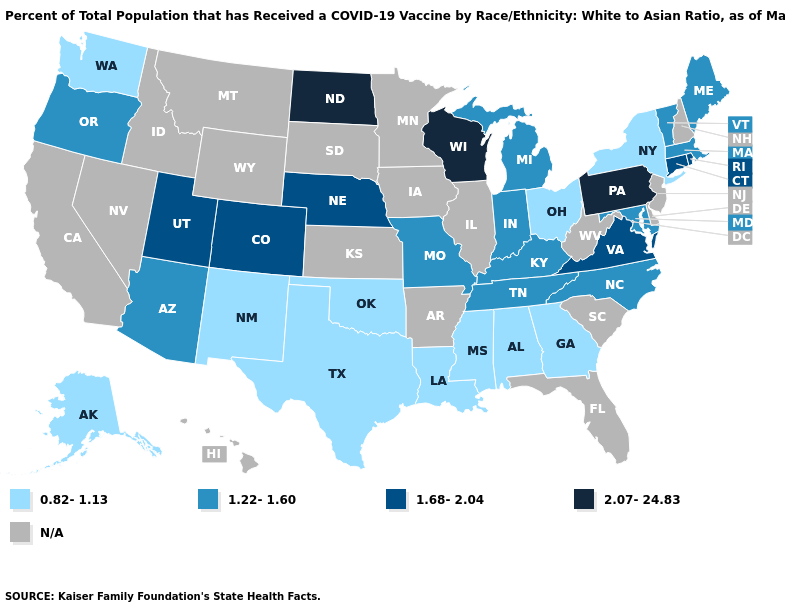Is the legend a continuous bar?
Keep it brief. No. Does Indiana have the lowest value in the USA?
Concise answer only. No. What is the lowest value in states that border Mississippi?
Answer briefly. 0.82-1.13. What is the value of California?
Give a very brief answer. N/A. Does the first symbol in the legend represent the smallest category?
Write a very short answer. Yes. Among the states that border Delaware , which have the highest value?
Write a very short answer. Pennsylvania. What is the lowest value in the West?
Quick response, please. 0.82-1.13. Name the states that have a value in the range 1.68-2.04?
Be succinct. Colorado, Connecticut, Nebraska, Rhode Island, Utah, Virginia. Does the first symbol in the legend represent the smallest category?
Concise answer only. Yes. How many symbols are there in the legend?
Answer briefly. 5. What is the value of New York?
Keep it brief. 0.82-1.13. Is the legend a continuous bar?
Answer briefly. No. Which states have the lowest value in the USA?
Give a very brief answer. Alabama, Alaska, Georgia, Louisiana, Mississippi, New Mexico, New York, Ohio, Oklahoma, Texas, Washington. Which states have the lowest value in the USA?
Keep it brief. Alabama, Alaska, Georgia, Louisiana, Mississippi, New Mexico, New York, Ohio, Oklahoma, Texas, Washington. 